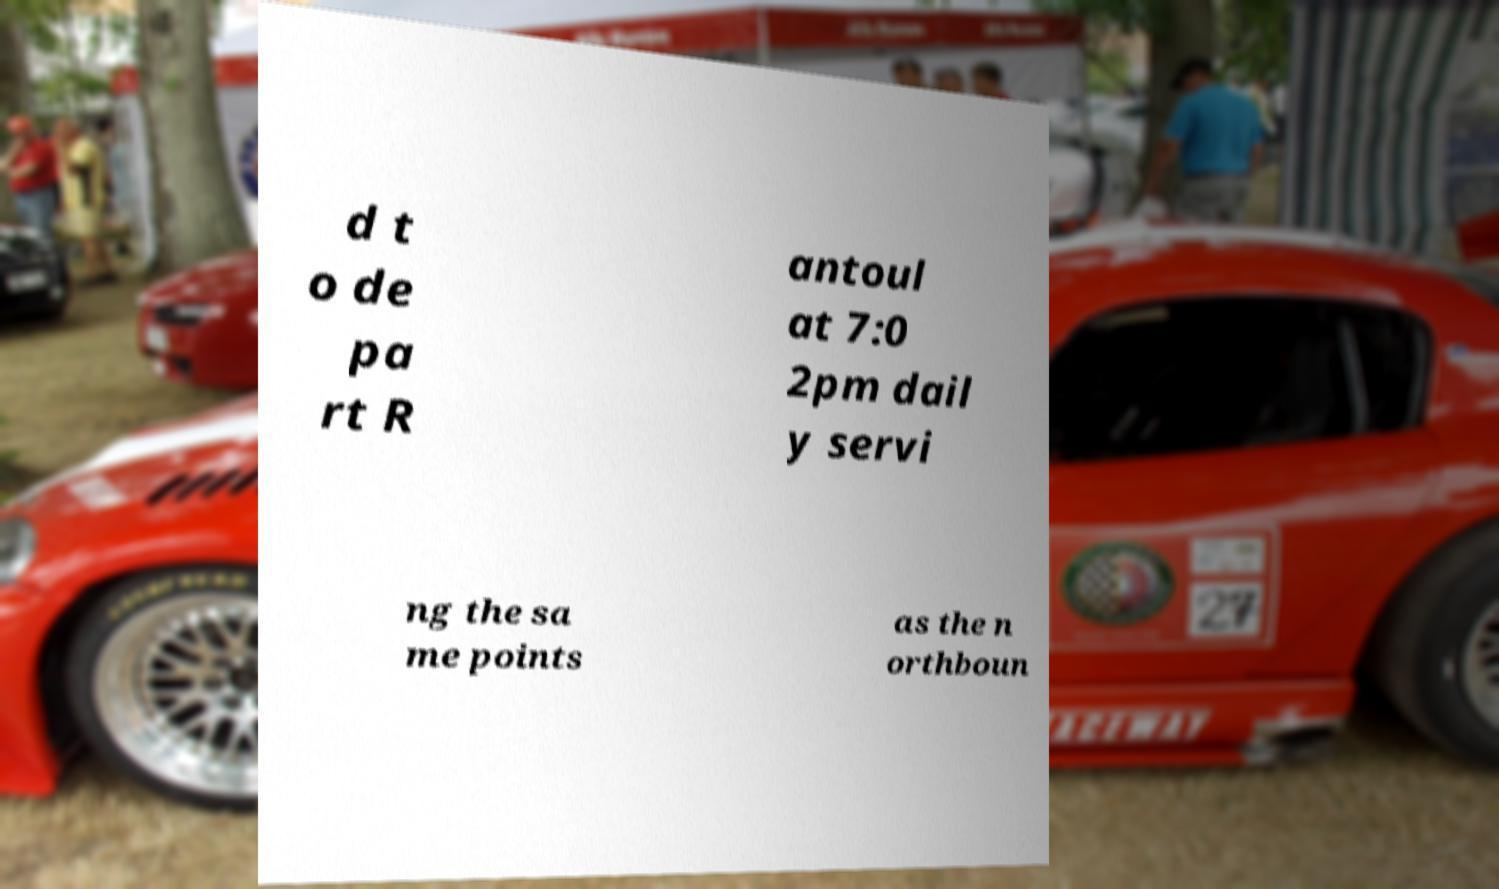Can you read and provide the text displayed in the image?This photo seems to have some interesting text. Can you extract and type it out for me? d t o de pa rt R antoul at 7:0 2pm dail y servi ng the sa me points as the n orthboun 